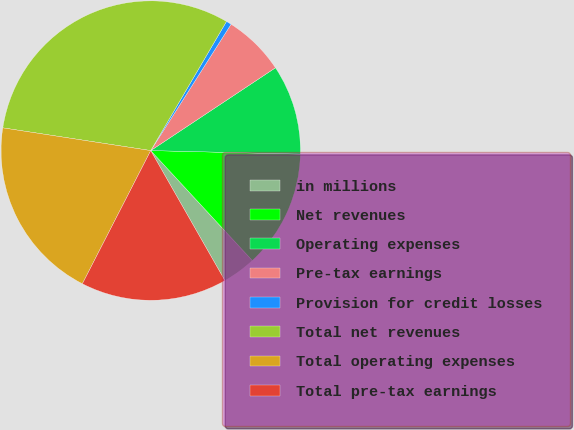Convert chart. <chart><loc_0><loc_0><loc_500><loc_500><pie_chart><fcel>in millions<fcel>Net revenues<fcel>Operating expenses<fcel>Pre-tax earnings<fcel>Provision for credit losses<fcel>Total net revenues<fcel>Total operating expenses<fcel>Total pre-tax earnings<nl><fcel>3.62%<fcel>12.75%<fcel>9.71%<fcel>6.66%<fcel>0.57%<fcel>31.02%<fcel>19.88%<fcel>15.8%<nl></chart> 